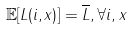<formula> <loc_0><loc_0><loc_500><loc_500>\mathbb { E } [ L ( i , x ) ] = \overline { L } , \forall i , x</formula> 